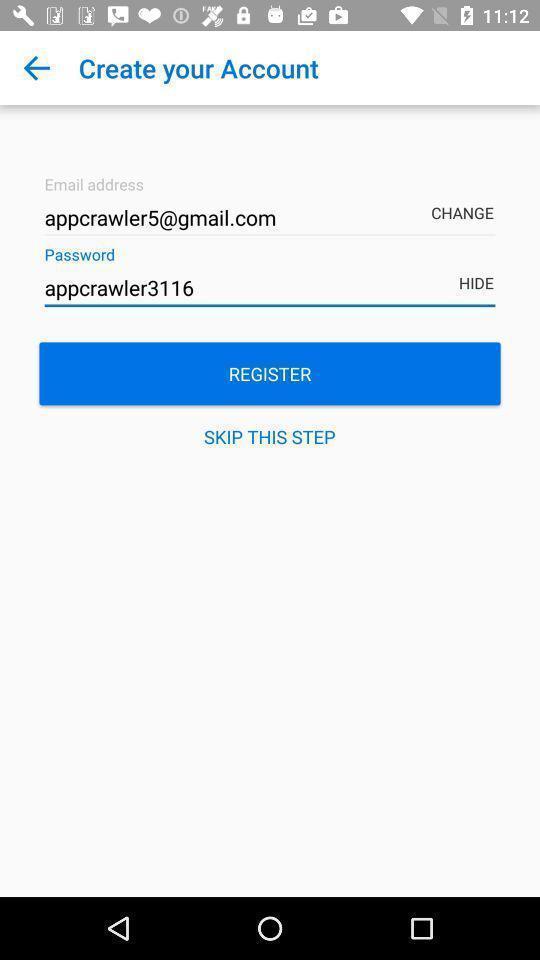Tell me about the visual elements in this screen capture. Sign up page to create an account. 